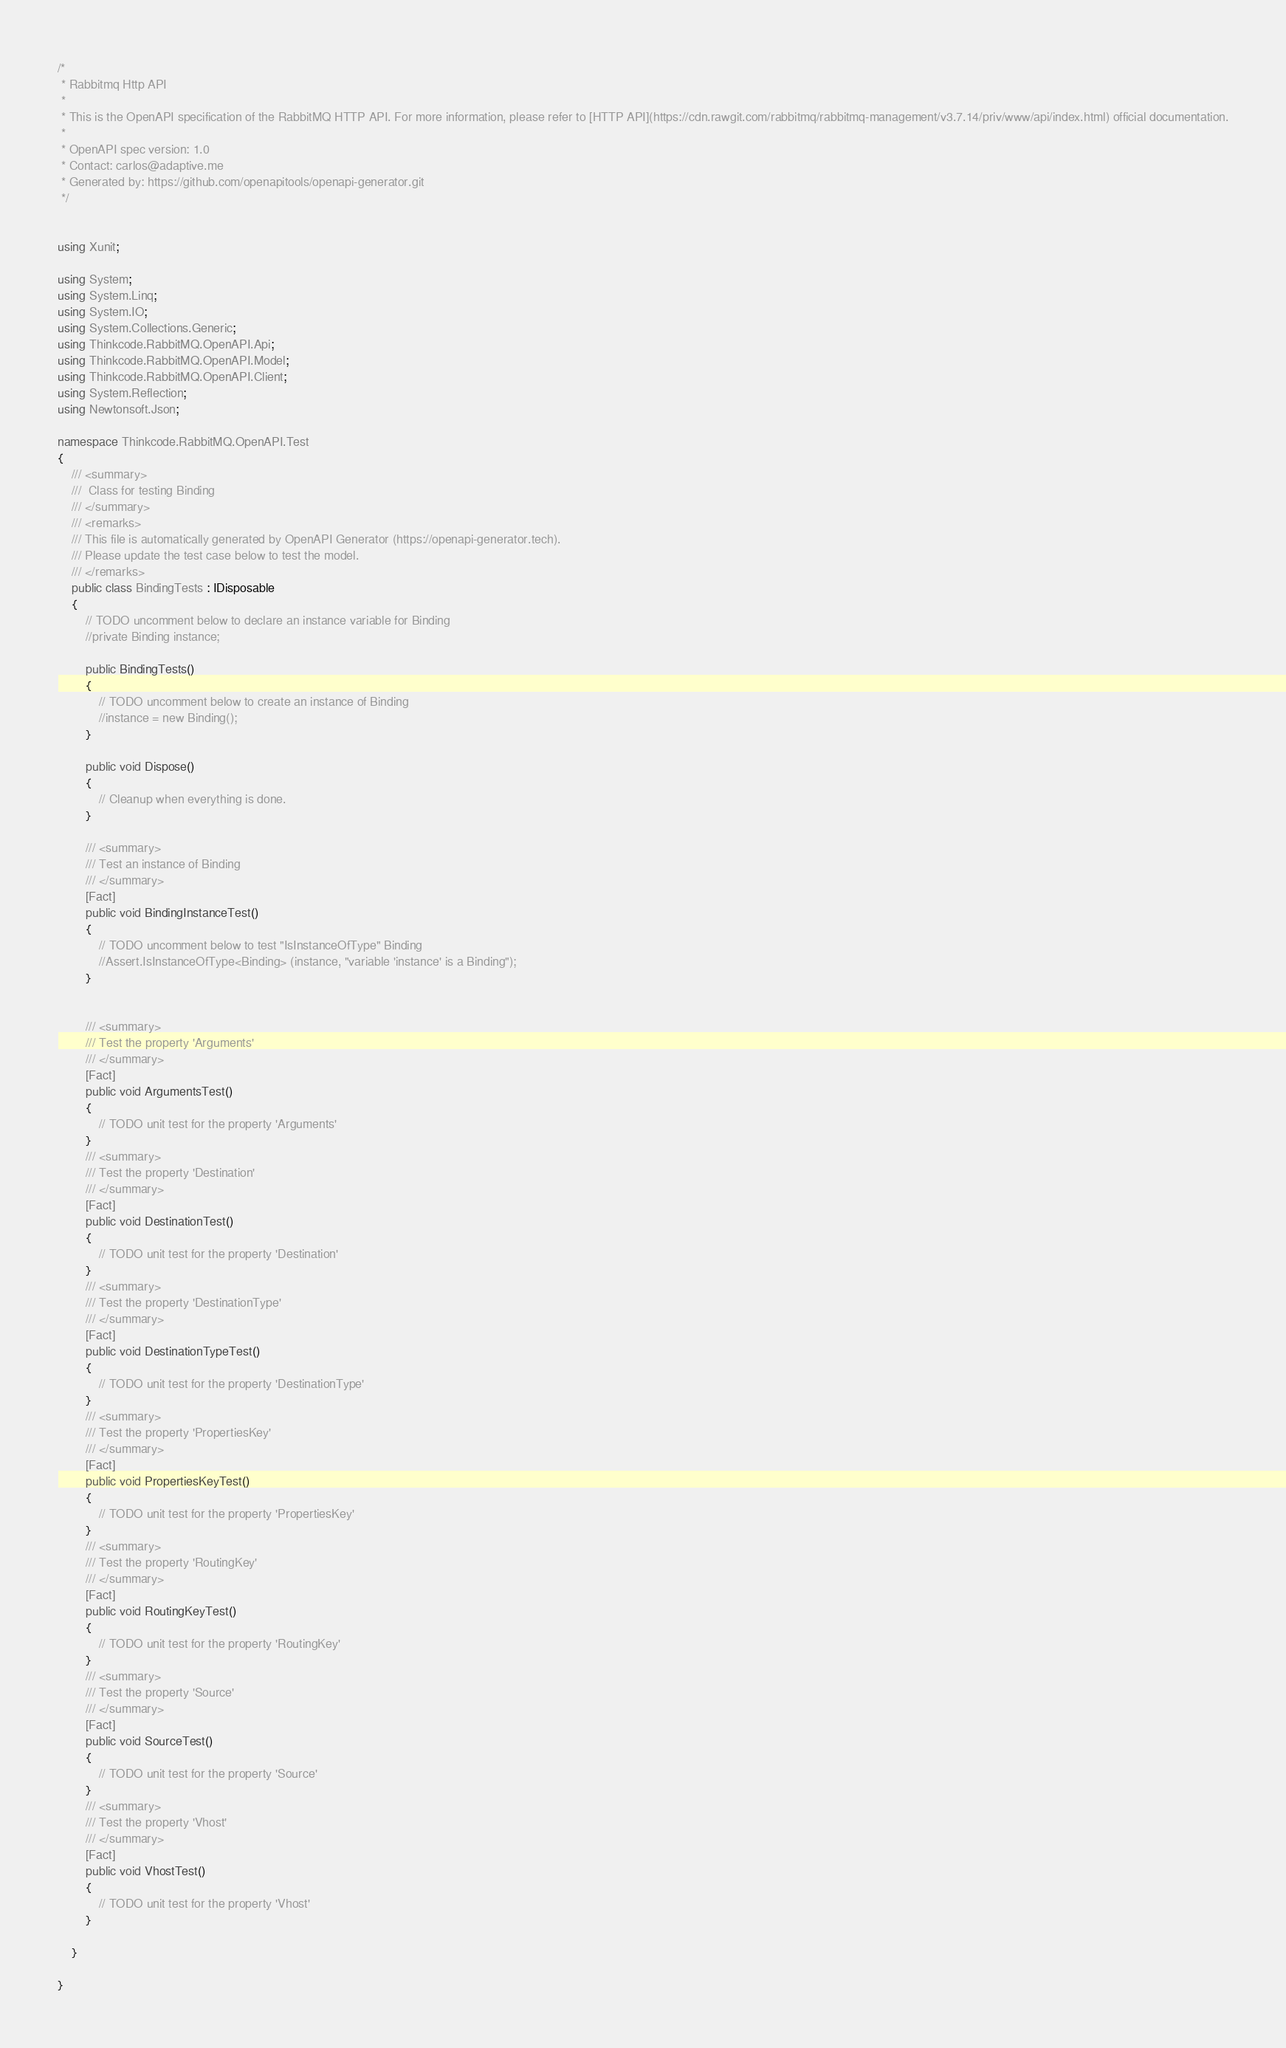Convert code to text. <code><loc_0><loc_0><loc_500><loc_500><_C#_>/* 
 * Rabbitmq Http API
 *
 * This is the OpenAPI specification of the RabbitMQ HTTP API. For more information, please refer to [HTTP API](https://cdn.rawgit.com/rabbitmq/rabbitmq-management/v3.7.14/priv/www/api/index.html) official documentation.
 *
 * OpenAPI spec version: 1.0
 * Contact: carlos@adaptive.me
 * Generated by: https://github.com/openapitools/openapi-generator.git
 */


using Xunit;

using System;
using System.Linq;
using System.IO;
using System.Collections.Generic;
using Thinkcode.RabbitMQ.OpenAPI.Api;
using Thinkcode.RabbitMQ.OpenAPI.Model;
using Thinkcode.RabbitMQ.OpenAPI.Client;
using System.Reflection;
using Newtonsoft.Json;

namespace Thinkcode.RabbitMQ.OpenAPI.Test
{
    /// <summary>
    ///  Class for testing Binding
    /// </summary>
    /// <remarks>
    /// This file is automatically generated by OpenAPI Generator (https://openapi-generator.tech).
    /// Please update the test case below to test the model.
    /// </remarks>
    public class BindingTests : IDisposable
    {
        // TODO uncomment below to declare an instance variable for Binding
        //private Binding instance;

        public BindingTests()
        {
            // TODO uncomment below to create an instance of Binding
            //instance = new Binding();
        }

        public void Dispose()
        {
            // Cleanup when everything is done.
        }

        /// <summary>
        /// Test an instance of Binding
        /// </summary>
        [Fact]
        public void BindingInstanceTest()
        {
            // TODO uncomment below to test "IsInstanceOfType" Binding
            //Assert.IsInstanceOfType<Binding> (instance, "variable 'instance' is a Binding");
        }


        /// <summary>
        /// Test the property 'Arguments'
        /// </summary>
        [Fact]
        public void ArgumentsTest()
        {
            // TODO unit test for the property 'Arguments'
        }
        /// <summary>
        /// Test the property 'Destination'
        /// </summary>
        [Fact]
        public void DestinationTest()
        {
            // TODO unit test for the property 'Destination'
        }
        /// <summary>
        /// Test the property 'DestinationType'
        /// </summary>
        [Fact]
        public void DestinationTypeTest()
        {
            // TODO unit test for the property 'DestinationType'
        }
        /// <summary>
        /// Test the property 'PropertiesKey'
        /// </summary>
        [Fact]
        public void PropertiesKeyTest()
        {
            // TODO unit test for the property 'PropertiesKey'
        }
        /// <summary>
        /// Test the property 'RoutingKey'
        /// </summary>
        [Fact]
        public void RoutingKeyTest()
        {
            // TODO unit test for the property 'RoutingKey'
        }
        /// <summary>
        /// Test the property 'Source'
        /// </summary>
        [Fact]
        public void SourceTest()
        {
            // TODO unit test for the property 'Source'
        }
        /// <summary>
        /// Test the property 'Vhost'
        /// </summary>
        [Fact]
        public void VhostTest()
        {
            // TODO unit test for the property 'Vhost'
        }

    }

}
</code> 